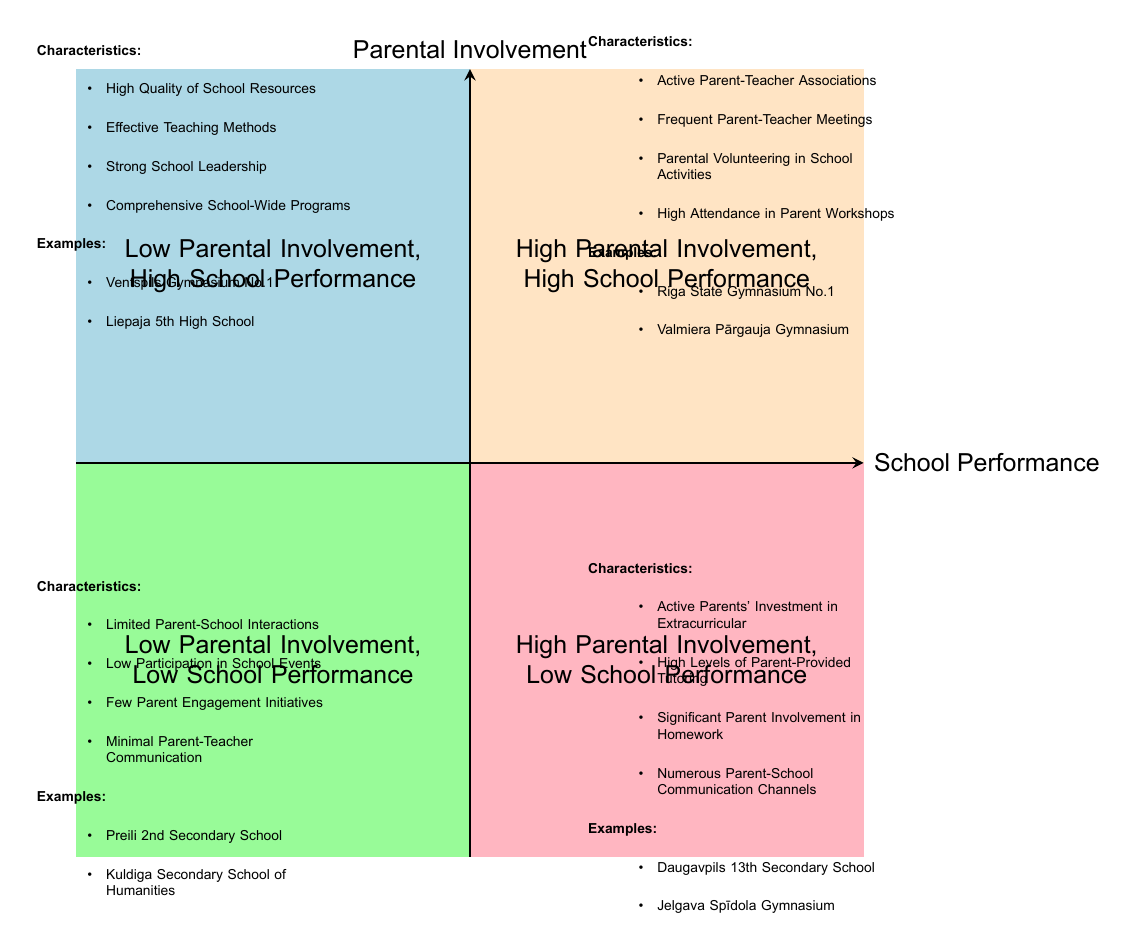What is in the top-left quadrant? The top-left quadrant represents "Low Parental Involvement, High School Performance," which is clearly labeled on the diagram.
Answer: Low Parental Involvement, High School Performance How many examples are listed in the "High Parental Involvement, Low School Performance" quadrant? The "High Parental Involvement, Low School Performance" quadrant lists two examples: Daugavpils 13th Secondary School and Jelgava Spīdola Gymnasium. There are a total of two examples noted.
Answer: 2 What are the characteristics of the "Low Parental Involvement, Low School Performance" quadrant? This quadrant has four characteristics: Limited Parent-School Interactions, Low Participation in School Events, Few Parent Engagement Initiatives, and Minimal Parent-Teacher Communication, all of which are outlined in the diagram.
Answer: Limited Parent-School Interactions, Low Participation in School Events, Few Parent Engagement Initiatives, Minimal Parent-Teacher Communication Which quadrant has "Active Parents' Investment in Extracurricular" as a characteristic? This characteristic is listed in the "High Parental Involvement, Low School Performance" quadrant, which is indicated on the diagram.
Answer: High Parental Involvement, Low School Performance What is the relationship between "High Parental Involvement" and "High School Performance"? The diagram shows that the relationship is positive, indicating that when parental involvement is high, school performance tends to be high as well, represented in the top-right quadrant.
Answer: Positive relationship Which quadrant contains a school with a name starting with "V"? The "Low Parental Involvement, High School Performance" quadrant lists Ventspils Gymnasium No.1 as an example school, which satisfies the question's condition.
Answer: Low Parental Involvement, High School Performance In how many quadrants is Riga State Gymnasium No.1 mentioned? Riga State Gymnasium No.1 is mentioned in the "High Parental Involvement, High School Performance" quadrant, indicating it appears in just one quadrant.
Answer: 1 What defines a "High Quality of School Resources" in the context of this diagram? This characteristic is part of the "Low Parental Involvement, High School Performance" quadrant, indicating that high-quality resources contribute to excellent school performance despite low parental involvement.
Answer: Low Parental Involvement, High School Performance 